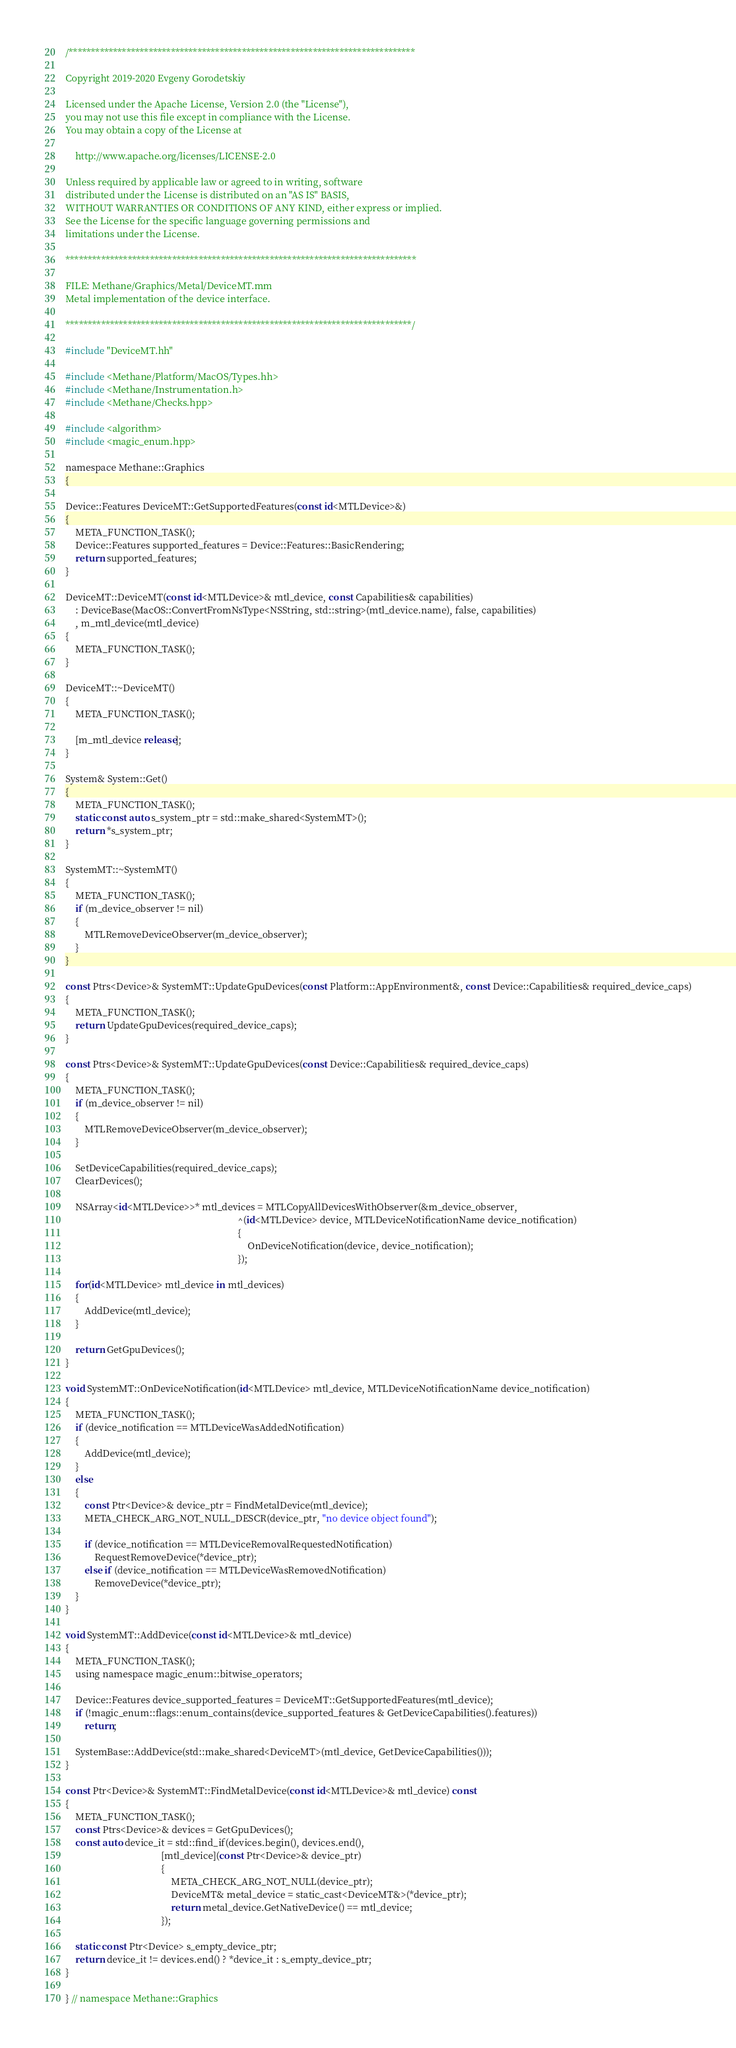Convert code to text. <code><loc_0><loc_0><loc_500><loc_500><_ObjectiveC_>/******************************************************************************

Copyright 2019-2020 Evgeny Gorodetskiy

Licensed under the Apache License, Version 2.0 (the "License"),
you may not use this file except in compliance with the License.
You may obtain a copy of the License at

    http://www.apache.org/licenses/LICENSE-2.0

Unless required by applicable law or agreed to in writing, software
distributed under the License is distributed on an "AS IS" BASIS,
WITHOUT WARRANTIES OR CONDITIONS OF ANY KIND, either express or implied.
See the License for the specific language governing permissions and
limitations under the License.

*******************************************************************************

FILE: Methane/Graphics/Metal/DeviceMT.mm
Metal implementation of the device interface.

******************************************************************************/

#include "DeviceMT.hh"

#include <Methane/Platform/MacOS/Types.hh>
#include <Methane/Instrumentation.h>
#include <Methane/Checks.hpp>

#include <algorithm>
#include <magic_enum.hpp>

namespace Methane::Graphics
{

Device::Features DeviceMT::GetSupportedFeatures(const id<MTLDevice>&)
{
    META_FUNCTION_TASK();
    Device::Features supported_features = Device::Features::BasicRendering;
    return supported_features;
}

DeviceMT::DeviceMT(const id<MTLDevice>& mtl_device, const Capabilities& capabilities)
    : DeviceBase(MacOS::ConvertFromNsType<NSString, std::string>(mtl_device.name), false, capabilities)
    , m_mtl_device(mtl_device)
{
    META_FUNCTION_TASK();
}

DeviceMT::~DeviceMT()
{
    META_FUNCTION_TASK();

    [m_mtl_device release];
}

System& System::Get()
{
    META_FUNCTION_TASK();
    static const auto s_system_ptr = std::make_shared<SystemMT>();
    return *s_system_ptr;
}

SystemMT::~SystemMT()
{
    META_FUNCTION_TASK();
    if (m_device_observer != nil)
    {
        MTLRemoveDeviceObserver(m_device_observer);
    }
}

const Ptrs<Device>& SystemMT::UpdateGpuDevices(const Platform::AppEnvironment&, const Device::Capabilities& required_device_caps)
{
    META_FUNCTION_TASK();
    return UpdateGpuDevices(required_device_caps);
}

const Ptrs<Device>& SystemMT::UpdateGpuDevices(const Device::Capabilities& required_device_caps)
{
    META_FUNCTION_TASK();
    if (m_device_observer != nil)
    {
        MTLRemoveDeviceObserver(m_device_observer);
    }

    SetDeviceCapabilities(required_device_caps);
    ClearDevices();
    
    NSArray<id<MTLDevice>>* mtl_devices = MTLCopyAllDevicesWithObserver(&m_device_observer,
                                                                        ^(id<MTLDevice> device, MTLDeviceNotificationName device_notification)
                                                                        {
                                                                            OnDeviceNotification(device, device_notification);
                                                                        });
    
    for(id<MTLDevice> mtl_device in mtl_devices)
    {
        AddDevice(mtl_device);
    }
    
    return GetGpuDevices();
}

void SystemMT::OnDeviceNotification(id<MTLDevice> mtl_device, MTLDeviceNotificationName device_notification)
{
    META_FUNCTION_TASK();
    if (device_notification == MTLDeviceWasAddedNotification)
    {
        AddDevice(mtl_device);
    }
    else
    {
        const Ptr<Device>& device_ptr = FindMetalDevice(mtl_device);
        META_CHECK_ARG_NOT_NULL_DESCR(device_ptr, "no device object found");

        if (device_notification == MTLDeviceRemovalRequestedNotification)
            RequestRemoveDevice(*device_ptr);
        else if (device_notification == MTLDeviceWasRemovedNotification)
            RemoveDevice(*device_ptr);
    }
}

void SystemMT::AddDevice(const id<MTLDevice>& mtl_device)
{
    META_FUNCTION_TASK();
    using namespace magic_enum::bitwise_operators;

    Device::Features device_supported_features = DeviceMT::GetSupportedFeatures(mtl_device);
    if (!magic_enum::flags::enum_contains(device_supported_features & GetDeviceCapabilities().features))
        return;

    SystemBase::AddDevice(std::make_shared<DeviceMT>(mtl_device, GetDeviceCapabilities()));
}

const Ptr<Device>& SystemMT::FindMetalDevice(const id<MTLDevice>& mtl_device) const
{
    META_FUNCTION_TASK();
    const Ptrs<Device>& devices = GetGpuDevices();
    const auto device_it = std::find_if(devices.begin(), devices.end(),
                                        [mtl_device](const Ptr<Device>& device_ptr)
                                        {
                                            META_CHECK_ARG_NOT_NULL(device_ptr);
                                            DeviceMT& metal_device = static_cast<DeviceMT&>(*device_ptr);
                                            return metal_device.GetNativeDevice() == mtl_device;
                                        });
    
    static const Ptr<Device> s_empty_device_ptr;
    return device_it != devices.end() ? *device_it : s_empty_device_ptr;
}

} // namespace Methane::Graphics
</code> 